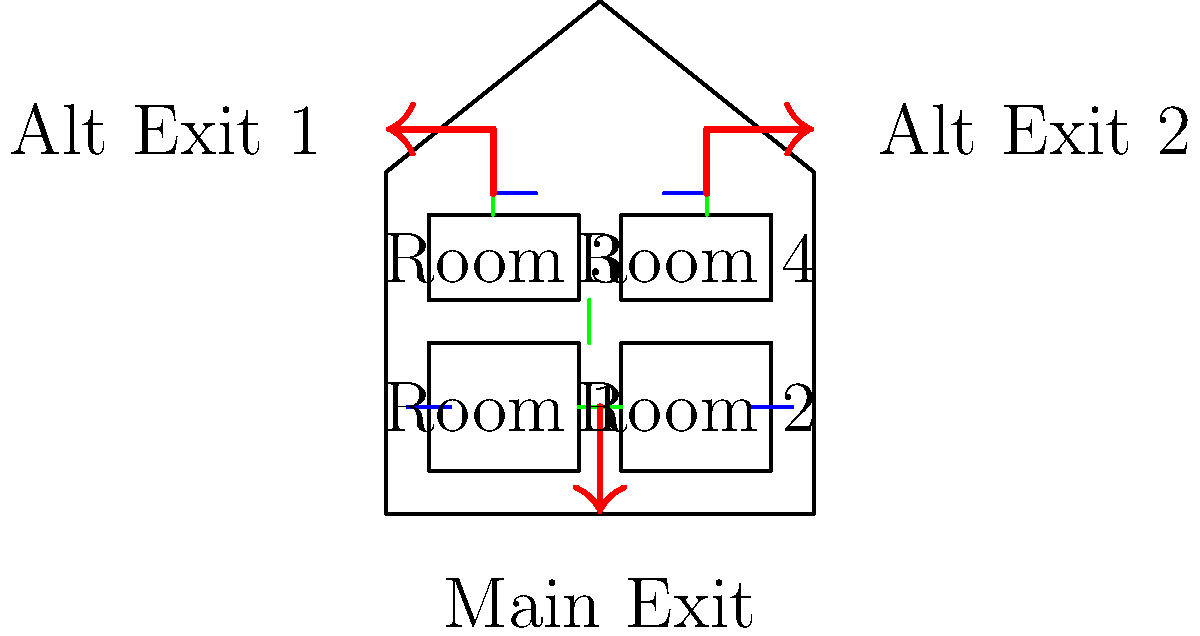In the home evacuation plan shown, which room has the most direct access to multiple exit routes, making it potentially the safest location during an emergency? To determine the safest room with the most direct access to multiple exit routes, let's analyze each room's proximity to the exits:

1. Room 1 (bottom left):
   - Has access to the main exit through Room 2
   - Can reach Alt Exit 1 through Room 3
   - Requires passing through two rooms for any exit

2. Room 2 (bottom right):
   - Has direct access to the main exit
   - Can reach Alt Exit 2 through Room 4
   - Requires passing through one room for an alternate exit

3. Room 3 (top left):
   - Has direct access to Alt Exit 1
   - Can reach the main exit through Room 4
   - Requires passing through one room for the main exit

4. Room 4 (top right):
   - Has direct access to Alt Exit 2
   - Has direct access to the main exit
   - Can reach both exits without passing through other rooms

Comparing all rooms, Room 4 has the most direct access to multiple exit routes. It has immediate access to both Alt Exit 2 and the main exit without needing to pass through any other rooms. This makes Room 4 potentially the safest location during an emergency, as it provides the most flexible and direct evacuation options.
Answer: Room 4 